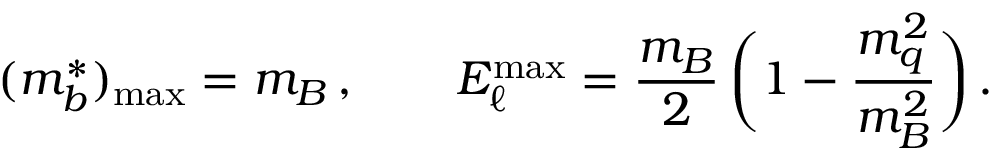Convert formula to latex. <formula><loc_0><loc_0><loc_500><loc_500>( m _ { b } ^ { * } ) _ { \max } = m _ { B } \, , \quad E _ { \ell } ^ { \max } = { \frac { m _ { B } } { 2 } } \, \left ( 1 - { \frac { m _ { q } ^ { 2 } } { m _ { B } ^ { 2 } } } \right ) \, .</formula> 